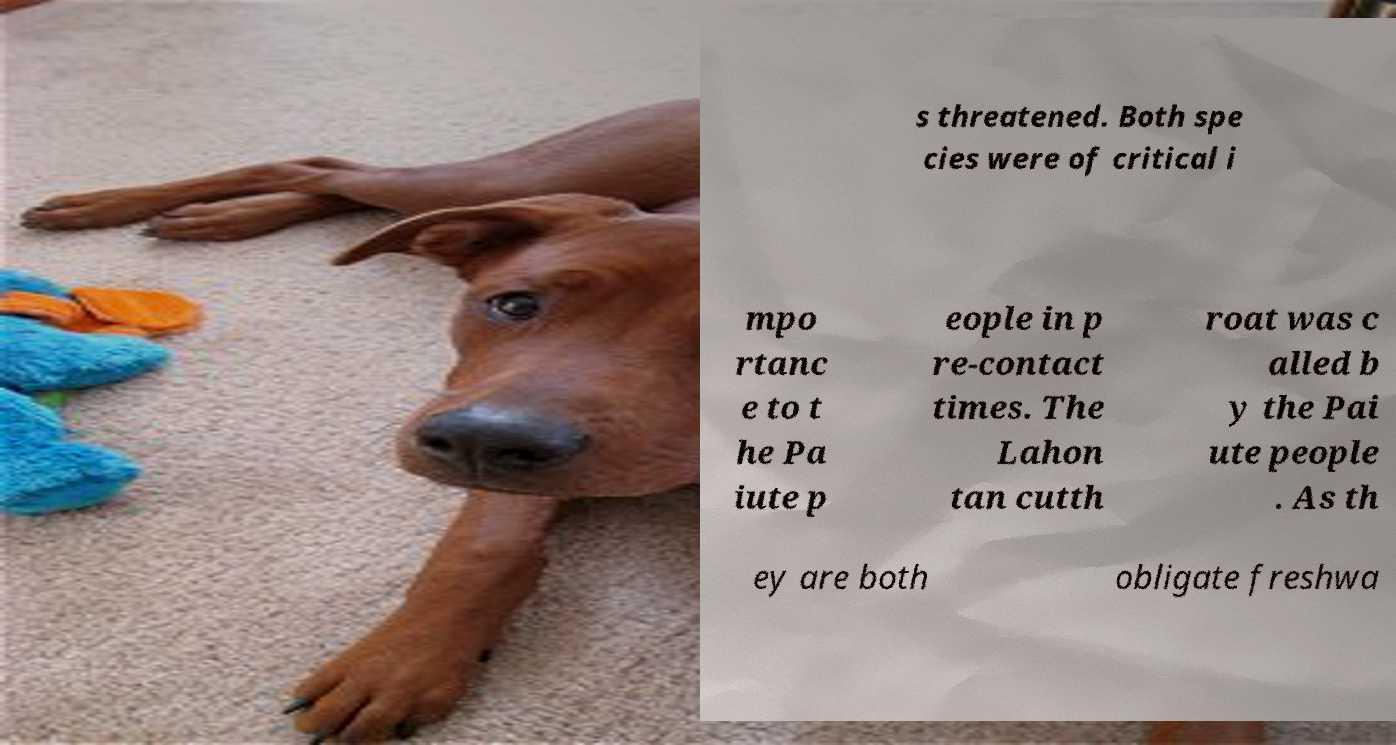I need the written content from this picture converted into text. Can you do that? s threatened. Both spe cies were of critical i mpo rtanc e to t he Pa iute p eople in p re-contact times. The Lahon tan cutth roat was c alled b y the Pai ute people . As th ey are both obligate freshwa 